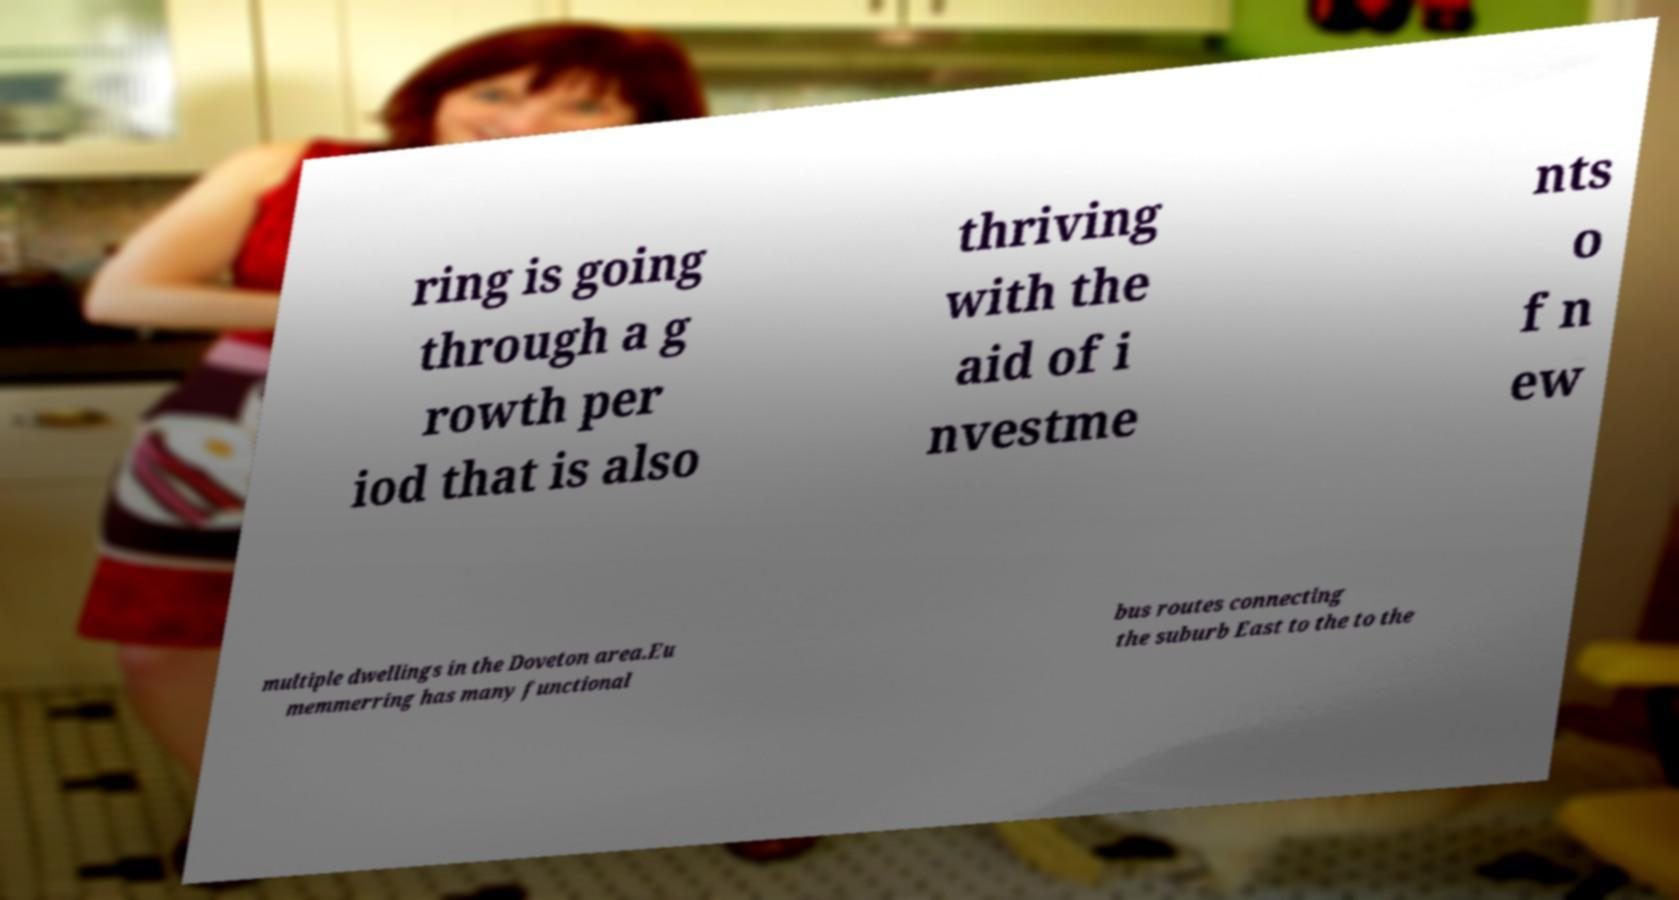What messages or text are displayed in this image? I need them in a readable, typed format. ring is going through a g rowth per iod that is also thriving with the aid of i nvestme nts o f n ew multiple dwellings in the Doveton area.Eu memmerring has many functional bus routes connecting the suburb East to the to the 